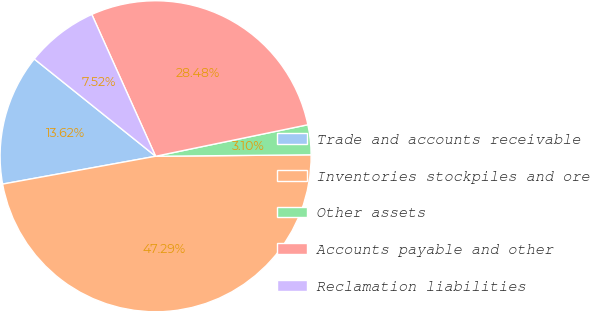Convert chart to OTSL. <chart><loc_0><loc_0><loc_500><loc_500><pie_chart><fcel>Trade and accounts receivable<fcel>Inventories stockpiles and ore<fcel>Other assets<fcel>Accounts payable and other<fcel>Reclamation liabilities<nl><fcel>13.62%<fcel>47.29%<fcel>3.1%<fcel>28.48%<fcel>7.52%<nl></chart> 